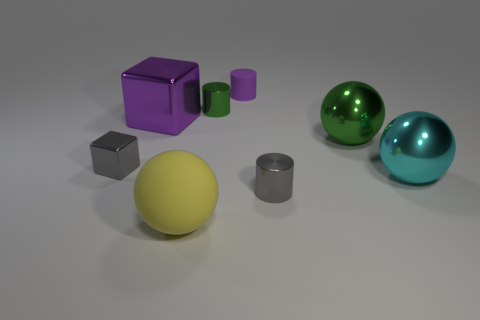Is the number of large cyan spheres on the left side of the cyan object less than the number of objects that are in front of the green cylinder?
Offer a very short reply. Yes. Is the size of the purple cylinder the same as the gray metallic thing that is behind the cyan metal thing?
Keep it short and to the point. Yes. How many purple rubber objects have the same size as the yellow object?
Your answer should be compact. 0. What number of large objects are either purple cubes or yellow balls?
Your answer should be compact. 2. Are there any blue cylinders?
Ensure brevity in your answer.  No. Are there more green objects that are on the right side of the purple cylinder than cyan metallic balls that are in front of the matte ball?
Keep it short and to the point. Yes. The matte object that is in front of the large metallic thing to the left of the tiny green shiny thing is what color?
Your response must be concise. Yellow. Is there a tiny metallic thing of the same color as the small metallic block?
Your answer should be compact. Yes. How big is the green metal object behind the large purple block that is behind the shiny thing that is to the right of the large green metal object?
Your answer should be very brief. Small. What is the shape of the big matte object?
Offer a very short reply. Sphere. 